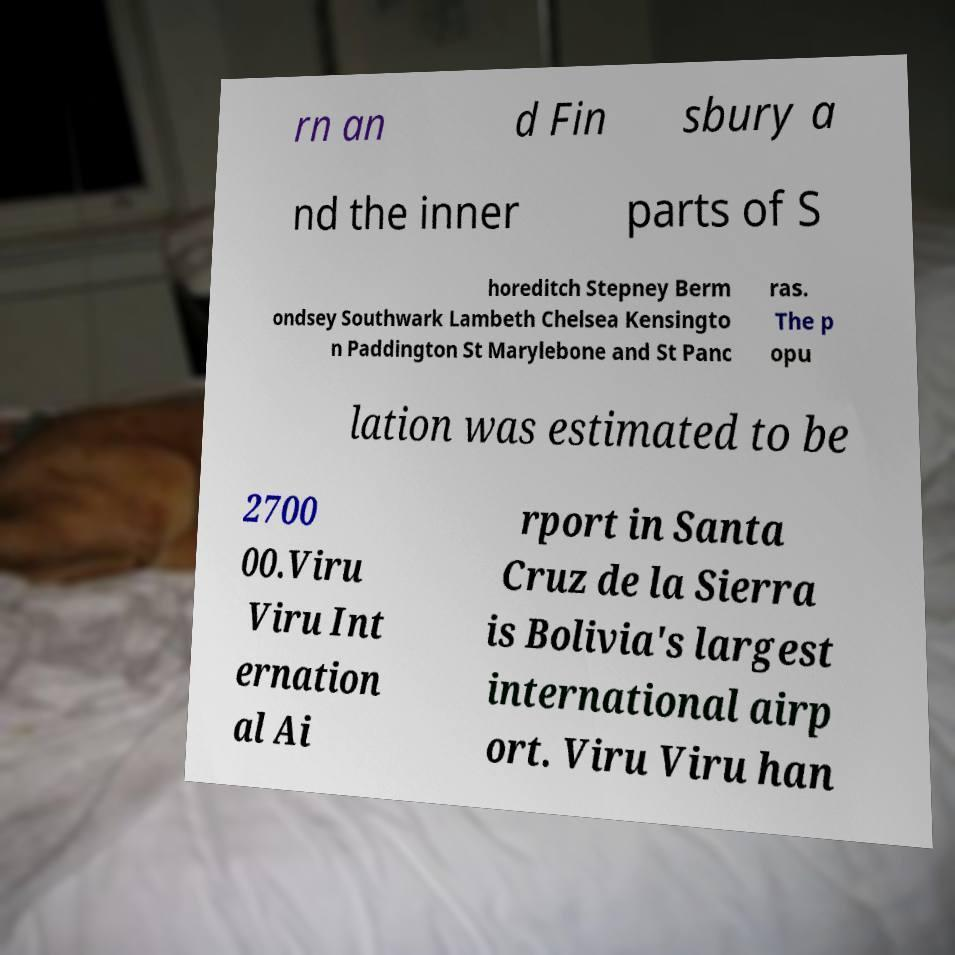Could you assist in decoding the text presented in this image and type it out clearly? rn an d Fin sbury a nd the inner parts of S horeditch Stepney Berm ondsey Southwark Lambeth Chelsea Kensingto n Paddington St Marylebone and St Panc ras. The p opu lation was estimated to be 2700 00.Viru Viru Int ernation al Ai rport in Santa Cruz de la Sierra is Bolivia's largest international airp ort. Viru Viru han 